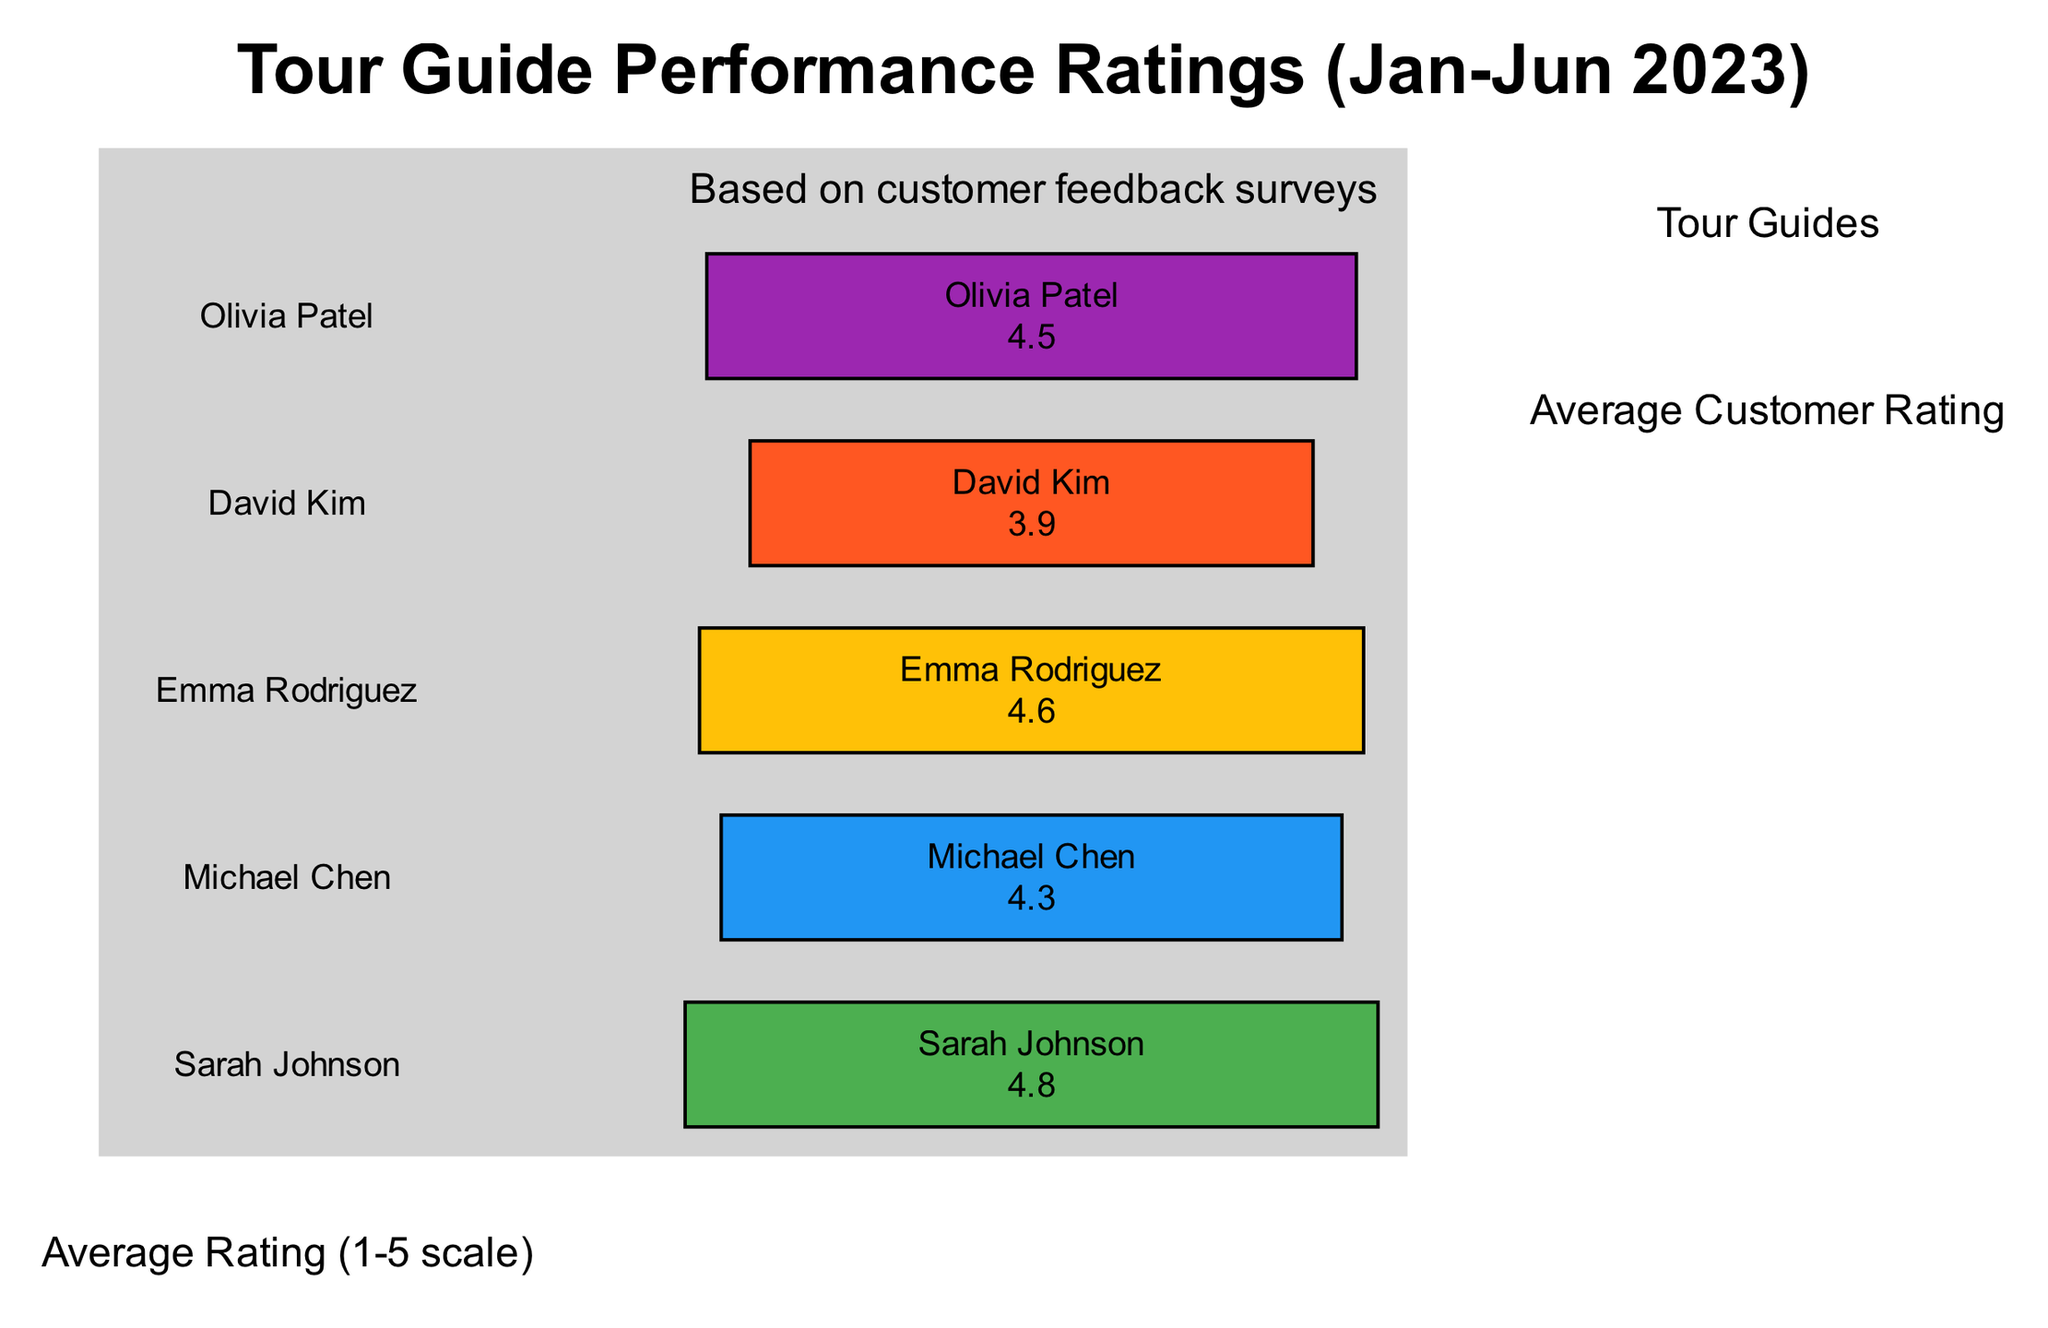What is the average rating of Sarah Johnson? The diagram indicates that Sarah Johnson has an average rating of 4.8. This information can be found directly alongside her name on the bar representing her rating.
Answer: 4.8 Which tour guide has the lowest performance rating? By examining the bar graph, David Kim is the guide with the lowest rating at 3.9. This rating is visually shorter than the others in the diagram.
Answer: David Kim What is the average rating of all tour guides combined? To find the average rating, add all the ratings together (4.8 + 4.3 + 4.6 + 3.9 + 4.5 = 22.1) and divide by the number of guides (5). The average results in 4.42, representing the overall performance of the tour guides in this period.
Answer: 4.42 How many tour guides have an average rating above 4.5? Looking at the ratings, Sarah Johnson and Emma Rodriguez have ratings above 4.5 (4.8 and 4.6 respectively), which totals to two guides. This can be deduced by counting the number of bars that surpass the 4.5 mark.
Answer: 2 What color represents Emma Rodriguez's rating? The bar color for Emma Rodriguez is represented by the color corresponding to 4.6, which is #FFC107. This color can be identified specifically next to her name on the diagram.
Answer: #FFC107 Relative to David Kim, how much higher is Michael Chen's rating? Michael Chen has an average rating of 4.3 while David Kim has a rating of 3.9. Subtracting David's from Michael's (4.3 - 3.9) gives 0.4, indicating that Michael's rating is 0.4 higher than David’s.
Answer: 0.4 What label appears at the top of the y-axis? The y-axis is labeled as "Average Rating (1-5 scale)", indicating the type of measurement used for the ratings provided in the graph. This label is shown directly along the vertical axis of the diagram.
Answer: Average Rating (1-5 scale) How many total tour guides are listed in this diagram? The diagram lists a total of five tour guides, visible by counting the names shown on the x-axis where each guide is labeled.
Answer: 5 